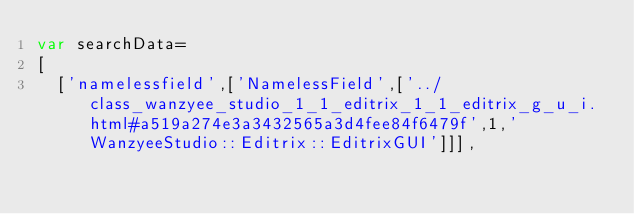<code> <loc_0><loc_0><loc_500><loc_500><_JavaScript_>var searchData=
[
  ['namelessfield',['NamelessField',['../class_wanzyee_studio_1_1_editrix_1_1_editrix_g_u_i.html#a519a274e3a3432565a3d4fee84f6479f',1,'WanzyeeStudio::Editrix::EditrixGUI']]],</code> 